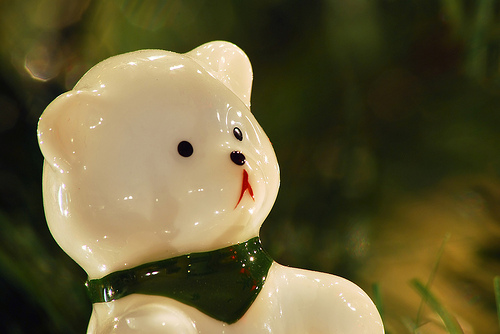<image>
Can you confirm if the bandana is on the bear? Yes. Looking at the image, I can see the bandana is positioned on top of the bear, with the bear providing support. 